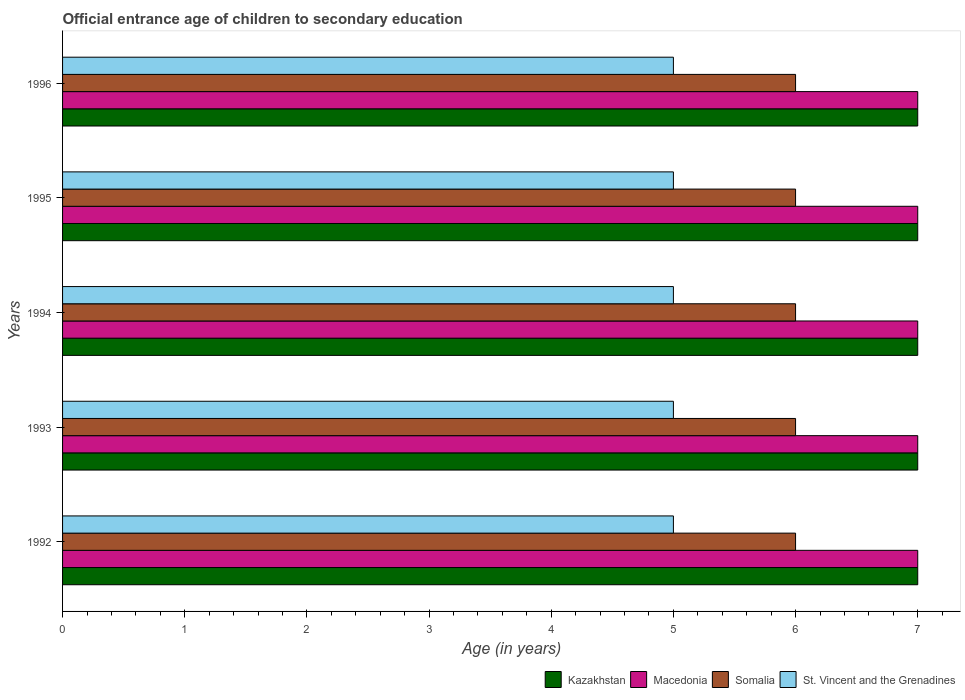Are the number of bars on each tick of the Y-axis equal?
Keep it short and to the point. Yes. How many bars are there on the 3rd tick from the top?
Your answer should be very brief. 4. How many bars are there on the 3rd tick from the bottom?
Offer a terse response. 4. What is the secondary school starting age of children in St. Vincent and the Grenadines in 1994?
Give a very brief answer. 5. Across all years, what is the maximum secondary school starting age of children in St. Vincent and the Grenadines?
Provide a short and direct response. 5. Across all years, what is the minimum secondary school starting age of children in Kazakhstan?
Your response must be concise. 7. What is the total secondary school starting age of children in St. Vincent and the Grenadines in the graph?
Offer a very short reply. 25. What is the difference between the secondary school starting age of children in Kazakhstan in 1992 and that in 1995?
Ensure brevity in your answer.  0. What is the difference between the secondary school starting age of children in Somalia in 1992 and the secondary school starting age of children in Macedonia in 1993?
Provide a succinct answer. -1. In the year 1996, what is the difference between the secondary school starting age of children in St. Vincent and the Grenadines and secondary school starting age of children in Macedonia?
Give a very brief answer. -2. What is the ratio of the secondary school starting age of children in St. Vincent and the Grenadines in 1992 to that in 1995?
Offer a terse response. 1. Is the secondary school starting age of children in Kazakhstan in 1995 less than that in 1996?
Provide a short and direct response. No. Is the difference between the secondary school starting age of children in St. Vincent and the Grenadines in 1995 and 1996 greater than the difference between the secondary school starting age of children in Macedonia in 1995 and 1996?
Your response must be concise. No. Is the sum of the secondary school starting age of children in St. Vincent and the Grenadines in 1992 and 1994 greater than the maximum secondary school starting age of children in Kazakhstan across all years?
Provide a succinct answer. Yes. What does the 2nd bar from the top in 1992 represents?
Your answer should be very brief. Somalia. What does the 1st bar from the bottom in 1993 represents?
Offer a very short reply. Kazakhstan. Is it the case that in every year, the sum of the secondary school starting age of children in Macedonia and secondary school starting age of children in Kazakhstan is greater than the secondary school starting age of children in St. Vincent and the Grenadines?
Make the answer very short. Yes. How many bars are there?
Keep it short and to the point. 20. Are all the bars in the graph horizontal?
Provide a short and direct response. Yes. What is the difference between two consecutive major ticks on the X-axis?
Make the answer very short. 1. Does the graph contain any zero values?
Make the answer very short. No. How are the legend labels stacked?
Keep it short and to the point. Horizontal. What is the title of the graph?
Ensure brevity in your answer.  Official entrance age of children to secondary education. What is the label or title of the X-axis?
Provide a succinct answer. Age (in years). What is the Age (in years) of Macedonia in 1992?
Keep it short and to the point. 7. What is the Age (in years) in St. Vincent and the Grenadines in 1992?
Provide a succinct answer. 5. What is the Age (in years) in Macedonia in 1993?
Your answer should be compact. 7. What is the Age (in years) of St. Vincent and the Grenadines in 1993?
Your response must be concise. 5. What is the Age (in years) of Kazakhstan in 1994?
Your answer should be compact. 7. What is the Age (in years) of Somalia in 1994?
Provide a succinct answer. 6. What is the Age (in years) in St. Vincent and the Grenadines in 1994?
Ensure brevity in your answer.  5. What is the Age (in years) in Somalia in 1995?
Keep it short and to the point. 6. What is the Age (in years) in Macedonia in 1996?
Keep it short and to the point. 7. Across all years, what is the maximum Age (in years) in Kazakhstan?
Your answer should be very brief. 7. Across all years, what is the maximum Age (in years) in Macedonia?
Ensure brevity in your answer.  7. Across all years, what is the maximum Age (in years) of Somalia?
Your answer should be compact. 6. Across all years, what is the minimum Age (in years) in St. Vincent and the Grenadines?
Offer a terse response. 5. What is the total Age (in years) of Kazakhstan in the graph?
Keep it short and to the point. 35. What is the difference between the Age (in years) in Macedonia in 1992 and that in 1993?
Give a very brief answer. 0. What is the difference between the Age (in years) in Macedonia in 1992 and that in 1994?
Provide a short and direct response. 0. What is the difference between the Age (in years) of Somalia in 1992 and that in 1994?
Provide a succinct answer. 0. What is the difference between the Age (in years) of St. Vincent and the Grenadines in 1992 and that in 1994?
Your response must be concise. 0. What is the difference between the Age (in years) of St. Vincent and the Grenadines in 1992 and that in 1995?
Make the answer very short. 0. What is the difference between the Age (in years) of Kazakhstan in 1992 and that in 1996?
Offer a very short reply. 0. What is the difference between the Age (in years) of Macedonia in 1992 and that in 1996?
Offer a terse response. 0. What is the difference between the Age (in years) of Macedonia in 1993 and that in 1994?
Make the answer very short. 0. What is the difference between the Age (in years) of Somalia in 1993 and that in 1994?
Offer a terse response. 0. What is the difference between the Age (in years) in St. Vincent and the Grenadines in 1993 and that in 1994?
Keep it short and to the point. 0. What is the difference between the Age (in years) in St. Vincent and the Grenadines in 1993 and that in 1995?
Offer a very short reply. 0. What is the difference between the Age (in years) in Kazakhstan in 1993 and that in 1996?
Provide a succinct answer. 0. What is the difference between the Age (in years) in Somalia in 1993 and that in 1996?
Your answer should be very brief. 0. What is the difference between the Age (in years) in Macedonia in 1994 and that in 1996?
Your response must be concise. 0. What is the difference between the Age (in years) of Macedonia in 1992 and the Age (in years) of Somalia in 1993?
Keep it short and to the point. 1. What is the difference between the Age (in years) in Somalia in 1992 and the Age (in years) in St. Vincent and the Grenadines in 1993?
Ensure brevity in your answer.  1. What is the difference between the Age (in years) of Kazakhstan in 1992 and the Age (in years) of Somalia in 1994?
Provide a short and direct response. 1. What is the difference between the Age (in years) in Kazakhstan in 1992 and the Age (in years) in St. Vincent and the Grenadines in 1994?
Make the answer very short. 2. What is the difference between the Age (in years) in Kazakhstan in 1992 and the Age (in years) in Macedonia in 1995?
Give a very brief answer. 0. What is the difference between the Age (in years) of Kazakhstan in 1992 and the Age (in years) of St. Vincent and the Grenadines in 1995?
Make the answer very short. 2. What is the difference between the Age (in years) in Kazakhstan in 1992 and the Age (in years) in Somalia in 1996?
Offer a terse response. 1. What is the difference between the Age (in years) in Somalia in 1992 and the Age (in years) in St. Vincent and the Grenadines in 1996?
Keep it short and to the point. 1. What is the difference between the Age (in years) of Kazakhstan in 1993 and the Age (in years) of Somalia in 1994?
Give a very brief answer. 1. What is the difference between the Age (in years) of Macedonia in 1993 and the Age (in years) of Somalia in 1994?
Offer a very short reply. 1. What is the difference between the Age (in years) of Macedonia in 1993 and the Age (in years) of St. Vincent and the Grenadines in 1995?
Provide a short and direct response. 2. What is the difference between the Age (in years) of Kazakhstan in 1993 and the Age (in years) of Macedonia in 1996?
Provide a short and direct response. 0. What is the difference between the Age (in years) of Kazakhstan in 1993 and the Age (in years) of St. Vincent and the Grenadines in 1996?
Ensure brevity in your answer.  2. What is the difference between the Age (in years) of Macedonia in 1993 and the Age (in years) of Somalia in 1996?
Ensure brevity in your answer.  1. What is the difference between the Age (in years) in Somalia in 1993 and the Age (in years) in St. Vincent and the Grenadines in 1996?
Keep it short and to the point. 1. What is the difference between the Age (in years) of Kazakhstan in 1994 and the Age (in years) of Somalia in 1995?
Provide a short and direct response. 1. What is the difference between the Age (in years) of Macedonia in 1994 and the Age (in years) of Somalia in 1995?
Make the answer very short. 1. What is the difference between the Age (in years) in Macedonia in 1994 and the Age (in years) in St. Vincent and the Grenadines in 1995?
Offer a very short reply. 2. What is the difference between the Age (in years) in Kazakhstan in 1994 and the Age (in years) in St. Vincent and the Grenadines in 1996?
Your answer should be compact. 2. What is the difference between the Age (in years) in Macedonia in 1994 and the Age (in years) in Somalia in 1996?
Offer a terse response. 1. What is the difference between the Age (in years) of Macedonia in 1994 and the Age (in years) of St. Vincent and the Grenadines in 1996?
Provide a succinct answer. 2. What is the difference between the Age (in years) in Somalia in 1994 and the Age (in years) in St. Vincent and the Grenadines in 1996?
Offer a very short reply. 1. What is the difference between the Age (in years) in Kazakhstan in 1995 and the Age (in years) in Somalia in 1996?
Your answer should be very brief. 1. What is the average Age (in years) of Kazakhstan per year?
Offer a very short reply. 7. What is the average Age (in years) of Macedonia per year?
Your response must be concise. 7. What is the average Age (in years) in Somalia per year?
Provide a succinct answer. 6. What is the average Age (in years) in St. Vincent and the Grenadines per year?
Offer a very short reply. 5. In the year 1992, what is the difference between the Age (in years) of Kazakhstan and Age (in years) of Macedonia?
Provide a short and direct response. 0. In the year 1992, what is the difference between the Age (in years) of Kazakhstan and Age (in years) of Somalia?
Provide a succinct answer. 1. In the year 1992, what is the difference between the Age (in years) of Macedonia and Age (in years) of Somalia?
Make the answer very short. 1. In the year 1993, what is the difference between the Age (in years) in Kazakhstan and Age (in years) in Macedonia?
Give a very brief answer. 0. In the year 1994, what is the difference between the Age (in years) of Macedonia and Age (in years) of Somalia?
Your answer should be very brief. 1. In the year 1994, what is the difference between the Age (in years) of Macedonia and Age (in years) of St. Vincent and the Grenadines?
Provide a short and direct response. 2. In the year 1994, what is the difference between the Age (in years) of Somalia and Age (in years) of St. Vincent and the Grenadines?
Provide a short and direct response. 1. In the year 1995, what is the difference between the Age (in years) in Kazakhstan and Age (in years) in St. Vincent and the Grenadines?
Make the answer very short. 2. In the year 1995, what is the difference between the Age (in years) of Macedonia and Age (in years) of Somalia?
Offer a terse response. 1. In the year 1995, what is the difference between the Age (in years) in Macedonia and Age (in years) in St. Vincent and the Grenadines?
Make the answer very short. 2. In the year 1996, what is the difference between the Age (in years) of Kazakhstan and Age (in years) of Macedonia?
Provide a succinct answer. 0. In the year 1996, what is the difference between the Age (in years) in Macedonia and Age (in years) in St. Vincent and the Grenadines?
Your answer should be compact. 2. In the year 1996, what is the difference between the Age (in years) of Somalia and Age (in years) of St. Vincent and the Grenadines?
Keep it short and to the point. 1. What is the ratio of the Age (in years) in Kazakhstan in 1992 to that in 1993?
Your answer should be very brief. 1. What is the ratio of the Age (in years) in Macedonia in 1992 to that in 1993?
Make the answer very short. 1. What is the ratio of the Age (in years) in Somalia in 1992 to that in 1993?
Provide a succinct answer. 1. What is the ratio of the Age (in years) in St. Vincent and the Grenadines in 1992 to that in 1993?
Provide a short and direct response. 1. What is the ratio of the Age (in years) in Kazakhstan in 1992 to that in 1995?
Your answer should be very brief. 1. What is the ratio of the Age (in years) of Macedonia in 1992 to that in 1995?
Keep it short and to the point. 1. What is the ratio of the Age (in years) of Somalia in 1992 to that in 1995?
Keep it short and to the point. 1. What is the ratio of the Age (in years) in St. Vincent and the Grenadines in 1992 to that in 1995?
Give a very brief answer. 1. What is the ratio of the Age (in years) of Kazakhstan in 1992 to that in 1996?
Ensure brevity in your answer.  1. What is the ratio of the Age (in years) of Macedonia in 1992 to that in 1996?
Your response must be concise. 1. What is the ratio of the Age (in years) in St. Vincent and the Grenadines in 1992 to that in 1996?
Offer a terse response. 1. What is the ratio of the Age (in years) of Somalia in 1993 to that in 1994?
Your answer should be very brief. 1. What is the ratio of the Age (in years) in Macedonia in 1993 to that in 1995?
Your answer should be compact. 1. What is the ratio of the Age (in years) of Somalia in 1993 to that in 1995?
Your response must be concise. 1. What is the ratio of the Age (in years) of Macedonia in 1993 to that in 1996?
Provide a short and direct response. 1. What is the ratio of the Age (in years) in Somalia in 1993 to that in 1996?
Your answer should be very brief. 1. What is the ratio of the Age (in years) in St. Vincent and the Grenadines in 1993 to that in 1996?
Your answer should be very brief. 1. What is the ratio of the Age (in years) of Somalia in 1994 to that in 1995?
Your answer should be very brief. 1. What is the ratio of the Age (in years) in St. Vincent and the Grenadines in 1994 to that in 1995?
Offer a very short reply. 1. What is the ratio of the Age (in years) in Kazakhstan in 1994 to that in 1996?
Provide a short and direct response. 1. What is the ratio of the Age (in years) of Macedonia in 1994 to that in 1996?
Your answer should be compact. 1. What is the ratio of the Age (in years) of St. Vincent and the Grenadines in 1994 to that in 1996?
Provide a short and direct response. 1. What is the ratio of the Age (in years) in Kazakhstan in 1995 to that in 1996?
Your answer should be very brief. 1. What is the ratio of the Age (in years) in Macedonia in 1995 to that in 1996?
Ensure brevity in your answer.  1. What is the ratio of the Age (in years) of Somalia in 1995 to that in 1996?
Offer a very short reply. 1. What is the ratio of the Age (in years) of St. Vincent and the Grenadines in 1995 to that in 1996?
Give a very brief answer. 1. What is the difference between the highest and the second highest Age (in years) of Somalia?
Keep it short and to the point. 0. What is the difference between the highest and the lowest Age (in years) of Kazakhstan?
Your answer should be very brief. 0. What is the difference between the highest and the lowest Age (in years) of Macedonia?
Make the answer very short. 0. What is the difference between the highest and the lowest Age (in years) in Somalia?
Provide a short and direct response. 0. What is the difference between the highest and the lowest Age (in years) in St. Vincent and the Grenadines?
Provide a succinct answer. 0. 